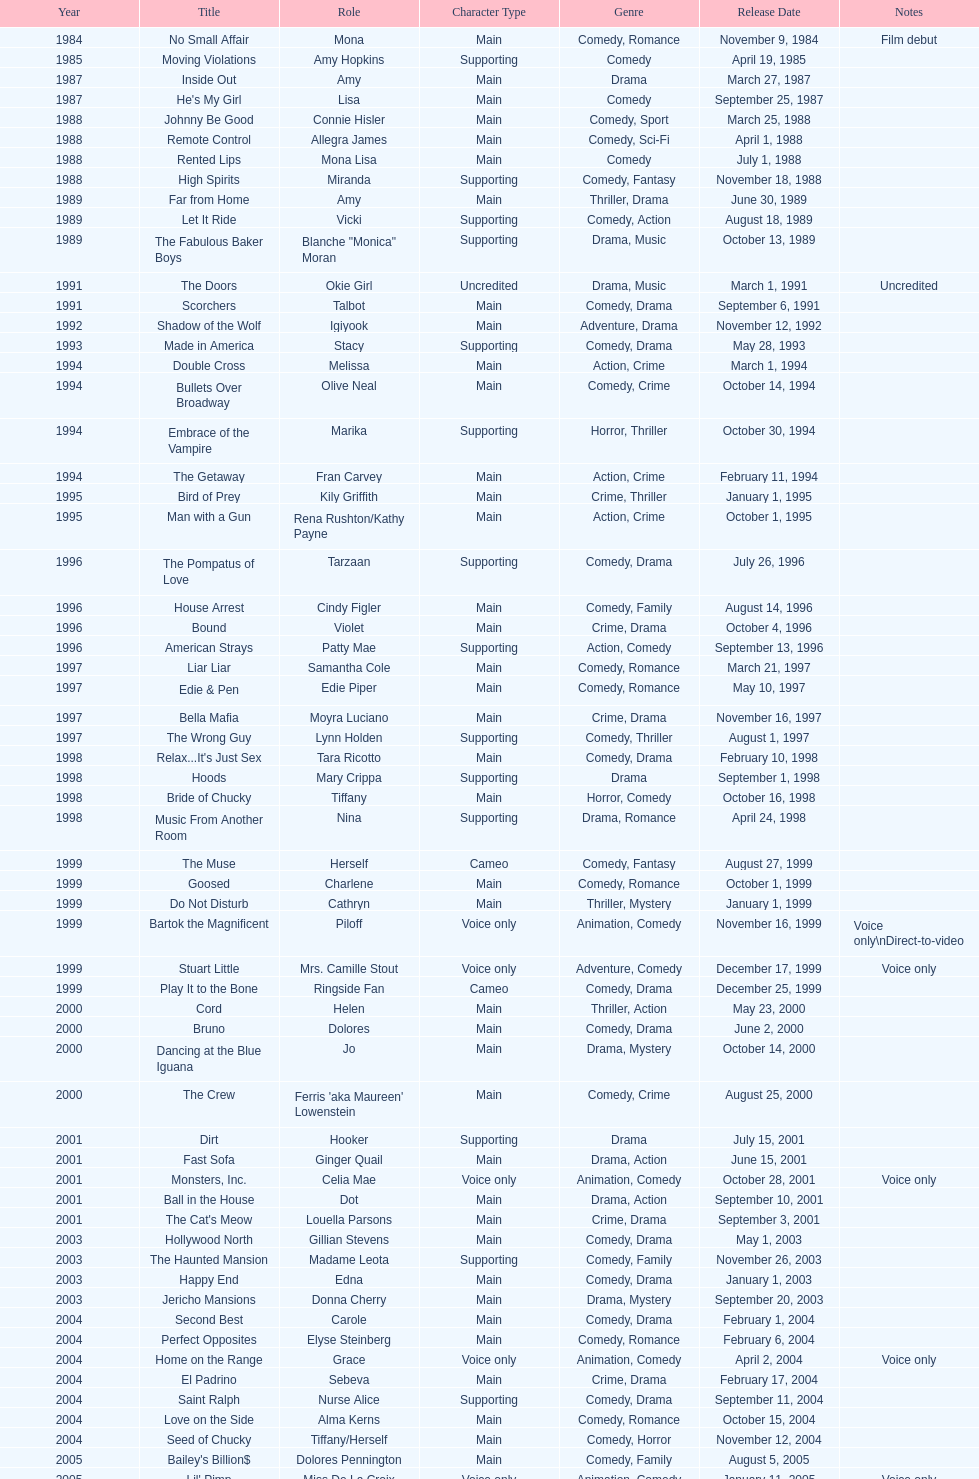How many movies does jennifer tilly play herself? 4. 